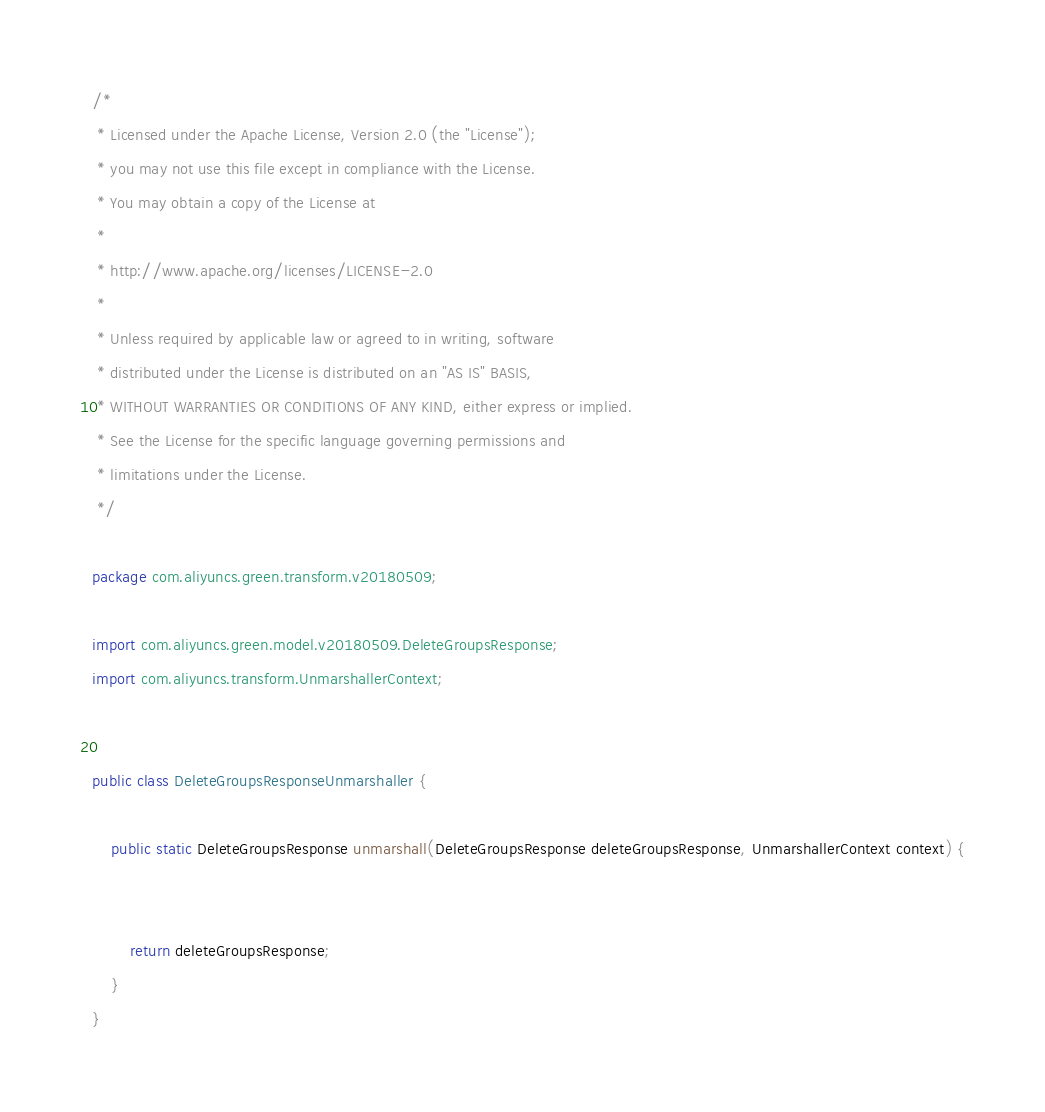<code> <loc_0><loc_0><loc_500><loc_500><_Java_>/*
 * Licensed under the Apache License, Version 2.0 (the "License");
 * you may not use this file except in compliance with the License.
 * You may obtain a copy of the License at
 *
 * http://www.apache.org/licenses/LICENSE-2.0
 *
 * Unless required by applicable law or agreed to in writing, software
 * distributed under the License is distributed on an "AS IS" BASIS,
 * WITHOUT WARRANTIES OR CONDITIONS OF ANY KIND, either express or implied.
 * See the License for the specific language governing permissions and
 * limitations under the License.
 */

package com.aliyuncs.green.transform.v20180509;

import com.aliyuncs.green.model.v20180509.DeleteGroupsResponse;
import com.aliyuncs.transform.UnmarshallerContext;


public class DeleteGroupsResponseUnmarshaller {

	public static DeleteGroupsResponse unmarshall(DeleteGroupsResponse deleteGroupsResponse, UnmarshallerContext context) {
		
	 
	 	return deleteGroupsResponse;
	}
}</code> 